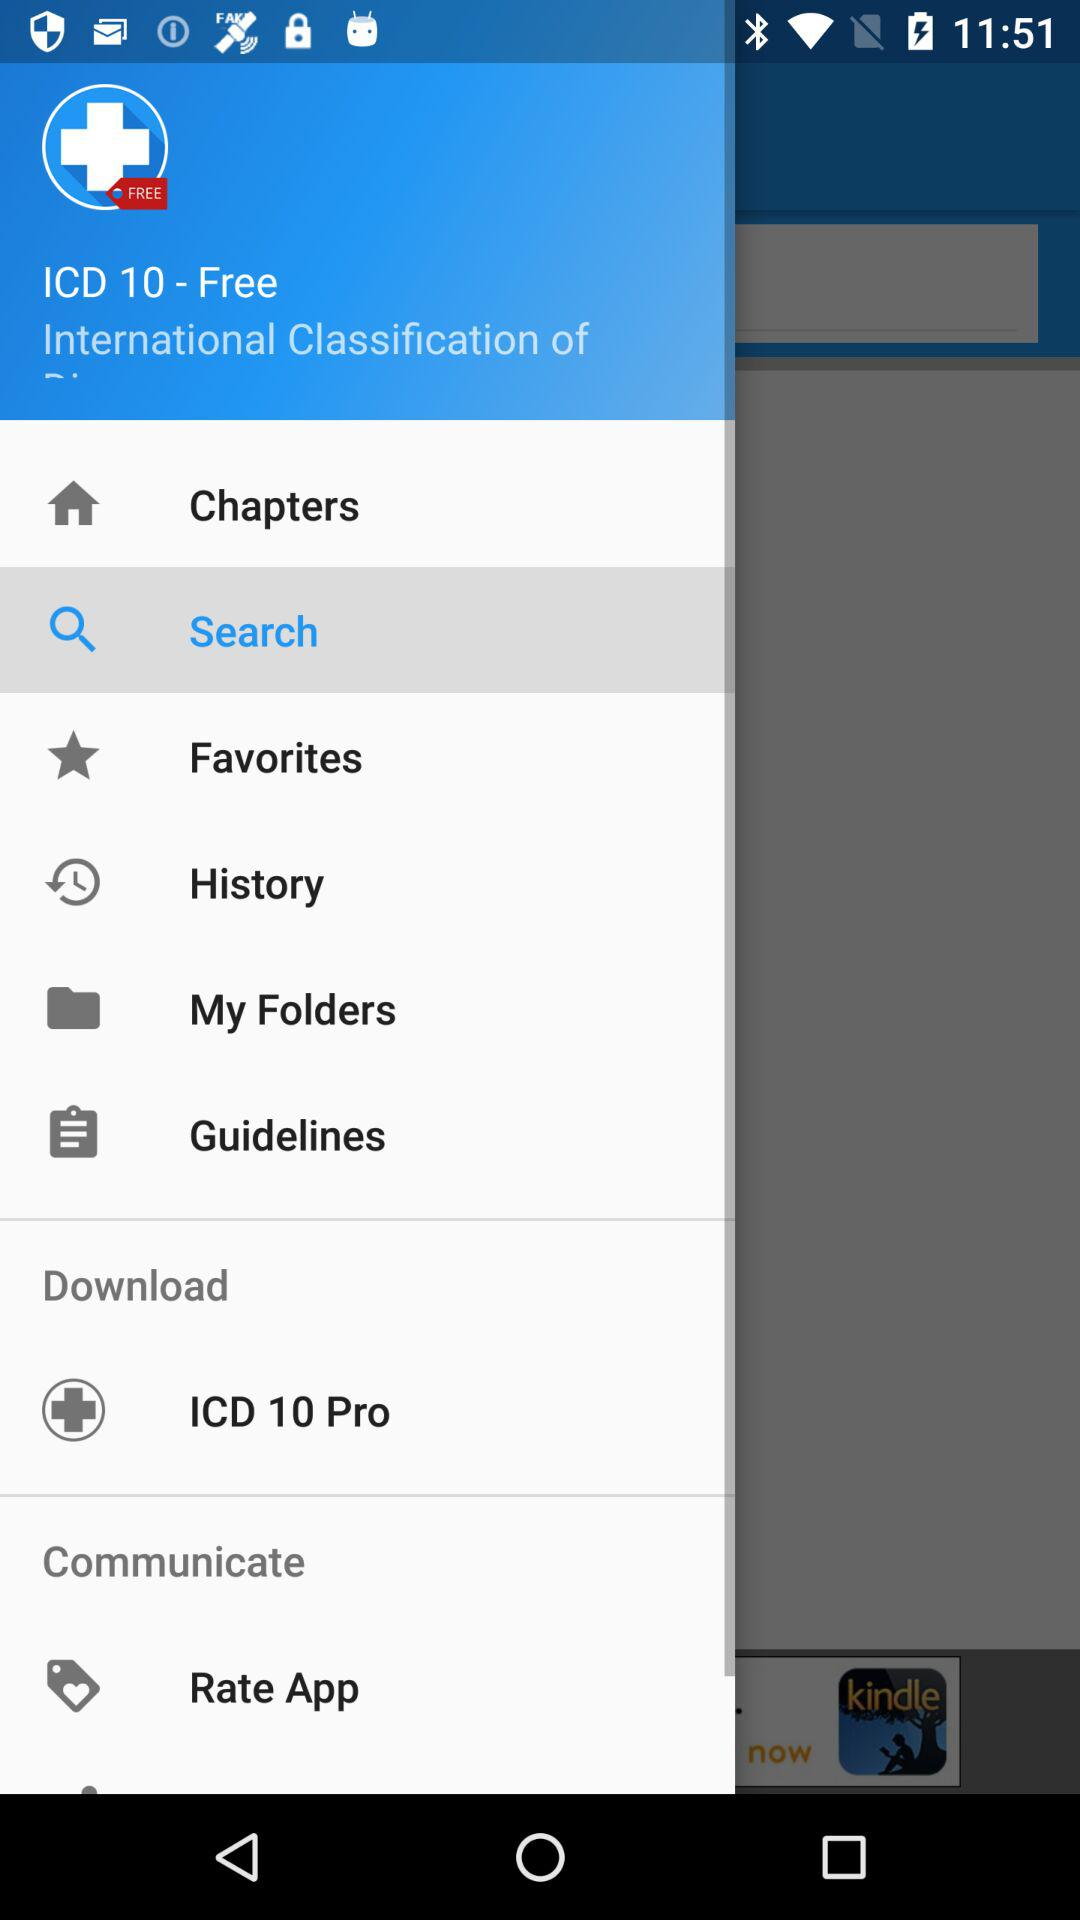Which item has been selected? The item that has been selected is "Search". 